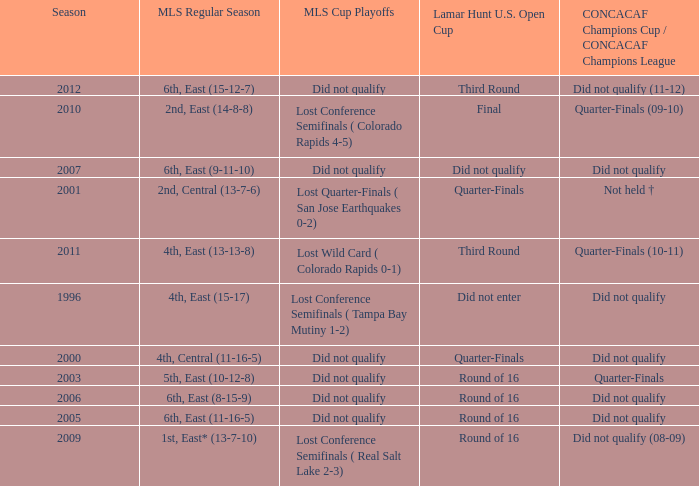What was the mls cup playoffs when concacaf champions cup / concacaf champions league was quarter-finals (09-10)? Lost Conference Semifinals ( Colorado Rapids 4-5). 